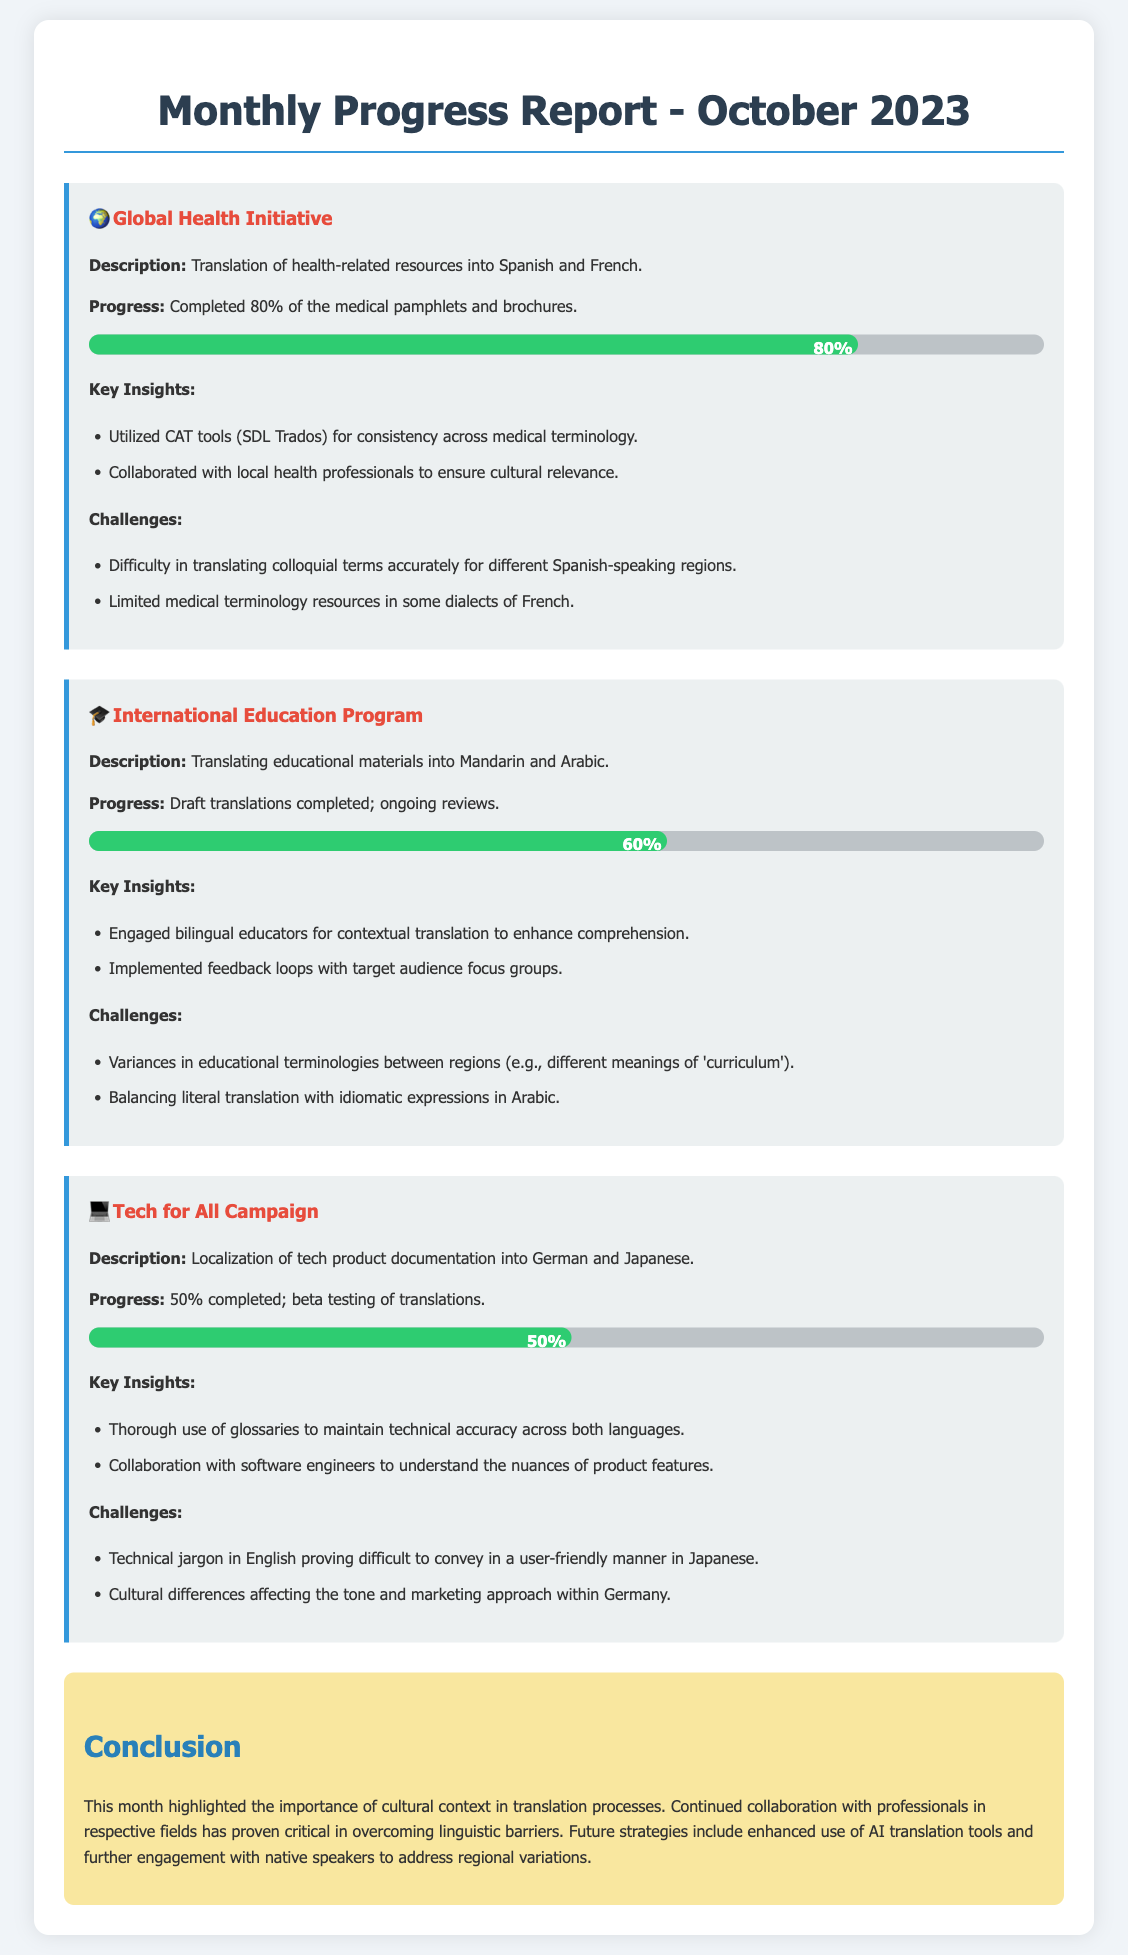What is the completion percentage of the Global Health Initiative project? The completion percentage for the Global Health Initiative project is explicitly stated in the document as 80%.
Answer: 80% What are the two languages involved in the International Education Program translation? The document mentions that the two languages for the International Education Program are Mandarin and Arabic.
Answer: Mandarin and Arabic Which translation tools were used for the Global Health Initiative? The document specifies that CAT tools, particularly SDL Trados, were utilized for consistency in medical terminology.
Answer: SDL Trados What is the current progress status of the Tech for All Campaign? The document states that the Tech for All Campaign project is 50% completed.
Answer: 50% What challenge did the Global Health Initiative face regarding colloquial terms? The document mentions that there was difficulty in translating colloquial terms accurately for different Spanish-speaking regions.
Answer: Difficulty in translating colloquial terms How does the document describe the importance of collaboration for translation projects? The conclusion highlights that continued collaboration with professionals in respective fields is critical in overcoming linguistic barriers.
Answer: Critical What was a noted challenge when translating educational terminologies in the International Education Program? The document specifies variances in educational terminologies between regions, such as different meanings of 'curriculum'.
Answer: Variances in educational terminologies What strategy does the conclusion suggest for the future of translation projects? The conclusion indicates that future strategies include enhanced use of AI translation tools and engagement with native speakers.
Answer: Enhanced use of AI translation tools 